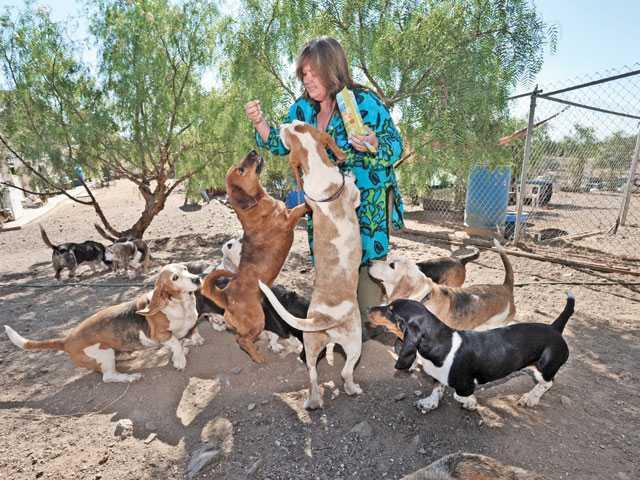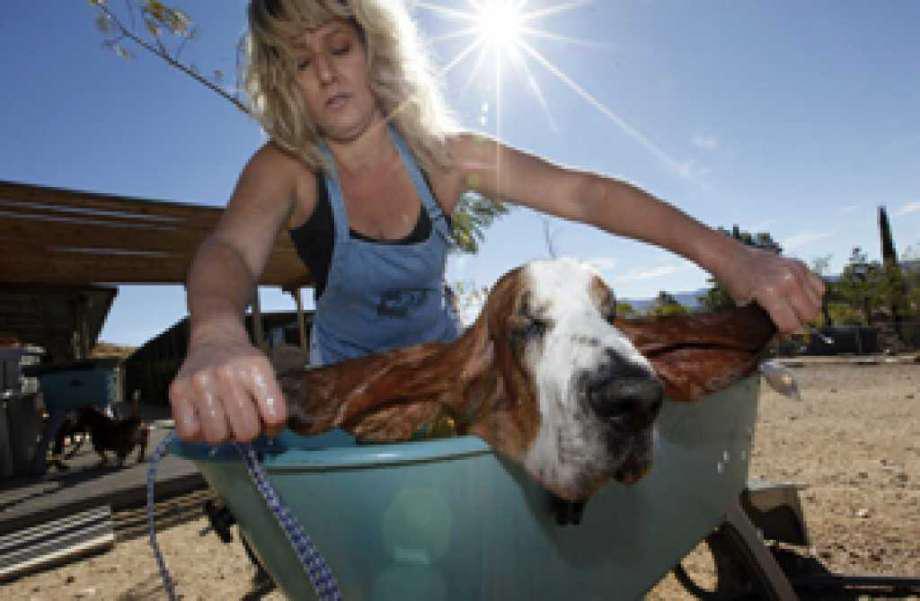The first image is the image on the left, the second image is the image on the right. Assess this claim about the two images: "A person in a tank top is bathing a dog outside.". Correct or not? Answer yes or no. Yes. The first image is the image on the left, the second image is the image on the right. Considering the images on both sides, is "An image shows a person behind a wash bucket containing a basset hound." valid? Answer yes or no. Yes. 